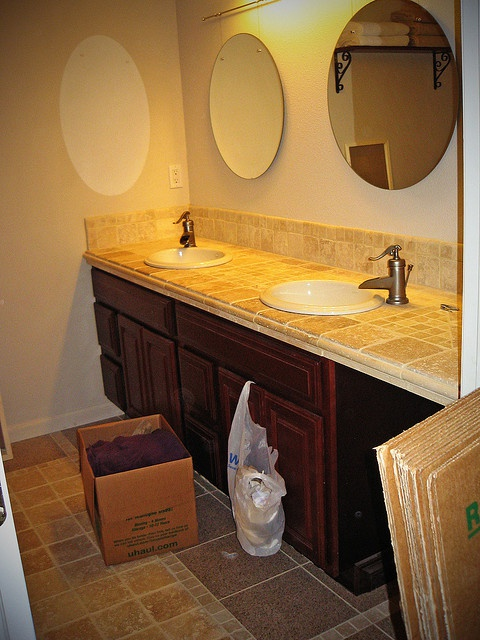Describe the objects in this image and their specific colors. I can see sink in maroon, tan, gold, and orange tones and sink in maroon, gold, orange, and khaki tones in this image. 